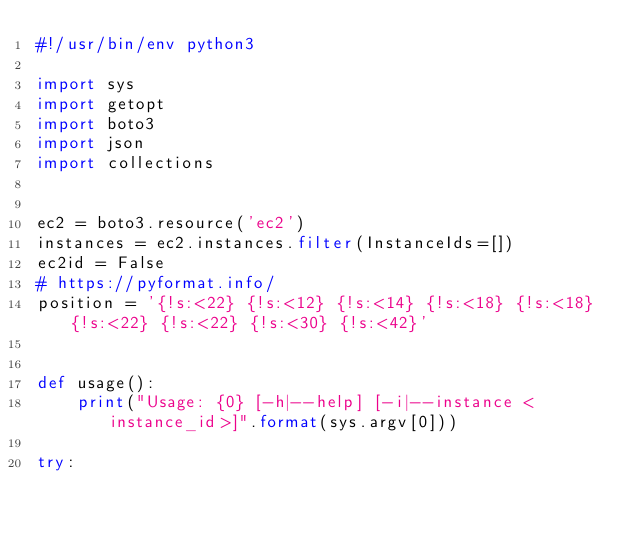<code> <loc_0><loc_0><loc_500><loc_500><_Python_>#!/usr/bin/env python3

import sys
import getopt
import boto3
import json
import collections


ec2 = boto3.resource('ec2')
instances = ec2.instances.filter(InstanceIds=[])
ec2id = False
# https://pyformat.info/
position = '{!s:<22} {!s:<12} {!s:<14} {!s:<18} {!s:<18} {!s:<22} {!s:<22} {!s:<30} {!s:<42}'


def usage():
    print("Usage: {0} [-h|--help] [-i|--instance <instance_id>]".format(sys.argv[0]))

try:</code> 